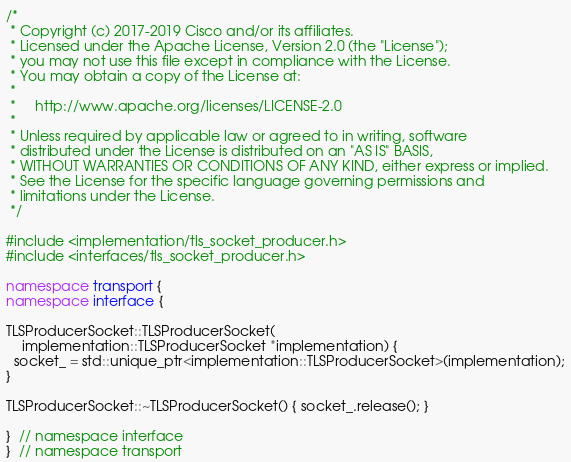Convert code to text. <code><loc_0><loc_0><loc_500><loc_500><_C++_>/*
 * Copyright (c) 2017-2019 Cisco and/or its affiliates.
 * Licensed under the Apache License, Version 2.0 (the "License");
 * you may not use this file except in compliance with the License.
 * You may obtain a copy of the License at:
 *
 *     http://www.apache.org/licenses/LICENSE-2.0
 *
 * Unless required by applicable law or agreed to in writing, software
 * distributed under the License is distributed on an "AS IS" BASIS,
 * WITHOUT WARRANTIES OR CONDITIONS OF ANY KIND, either express or implied.
 * See the License for the specific language governing permissions and
 * limitations under the License.
 */

#include <implementation/tls_socket_producer.h>
#include <interfaces/tls_socket_producer.h>

namespace transport {
namespace interface {

TLSProducerSocket::TLSProducerSocket(
    implementation::TLSProducerSocket *implementation) {
  socket_ = std::unique_ptr<implementation::TLSProducerSocket>(implementation);
}

TLSProducerSocket::~TLSProducerSocket() { socket_.release(); }

}  // namespace interface
}  // namespace transport
</code> 